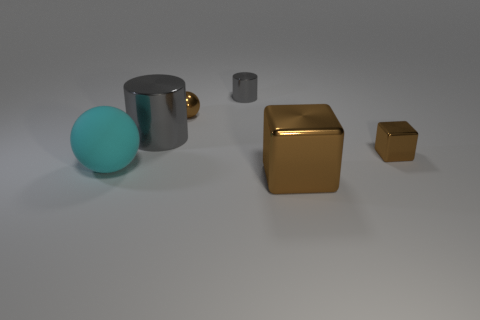If these objects were part of a still life composition, what themes might the artist be exploring? If this is an artistic still life, the artist might be exploring themes of geometry and contrast. The varied shapes — a sphere, a cylinder, and cubes — along with the contrast between the cool-colored sphere and the warm-toned metallic cubes could suggest an exploration of opposition. Additionally, the minimalist setting and spacing might symbolize isolation or simplicity. 